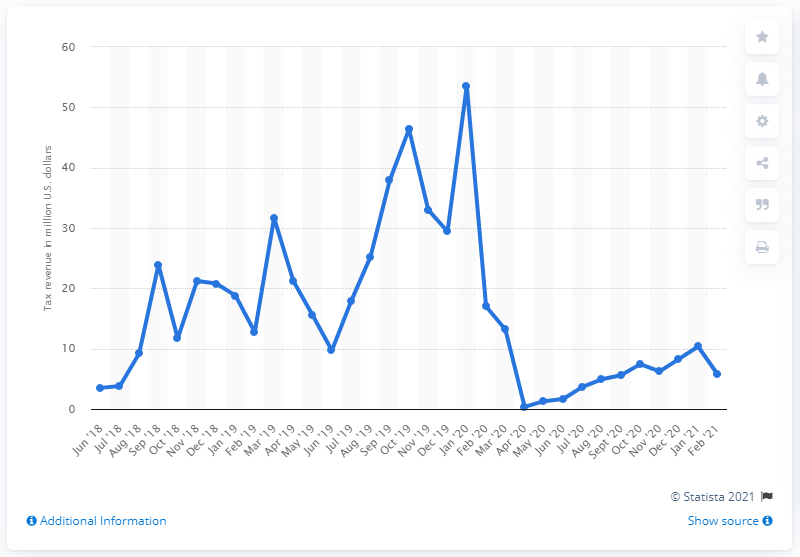Highlight a few significant elements in this photo. In February 2021, New Jersey generated $5.8 million in tax revenue from sports betting. The previous month's total in U.S. dollars for taxes from sports betting was 10.36. 